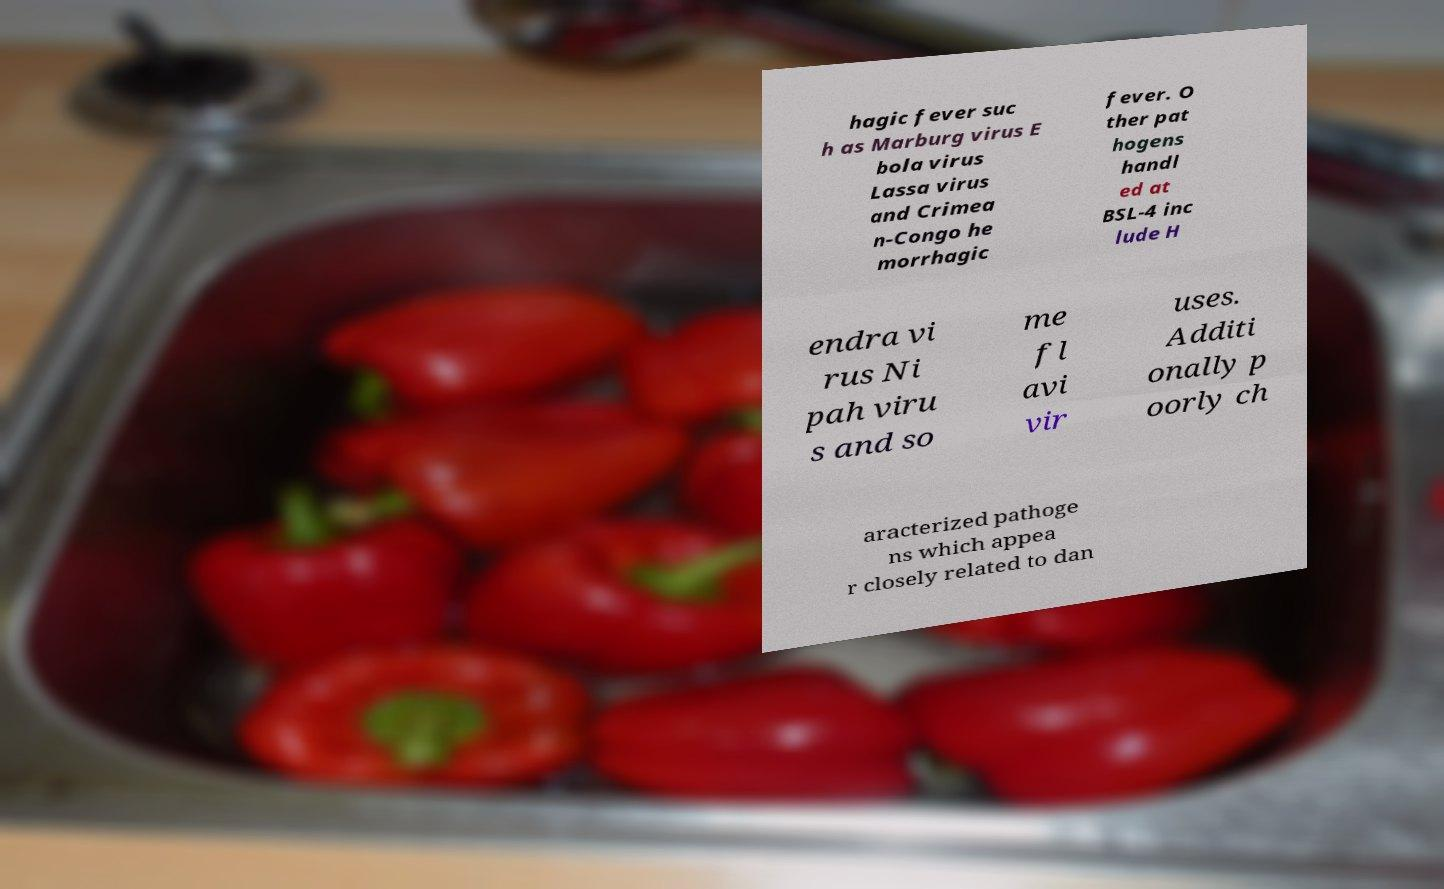Can you read and provide the text displayed in the image?This photo seems to have some interesting text. Can you extract and type it out for me? hagic fever suc h as Marburg virus E bola virus Lassa virus and Crimea n-Congo he morrhagic fever. O ther pat hogens handl ed at BSL-4 inc lude H endra vi rus Ni pah viru s and so me fl avi vir uses. Additi onally p oorly ch aracterized pathoge ns which appea r closely related to dan 